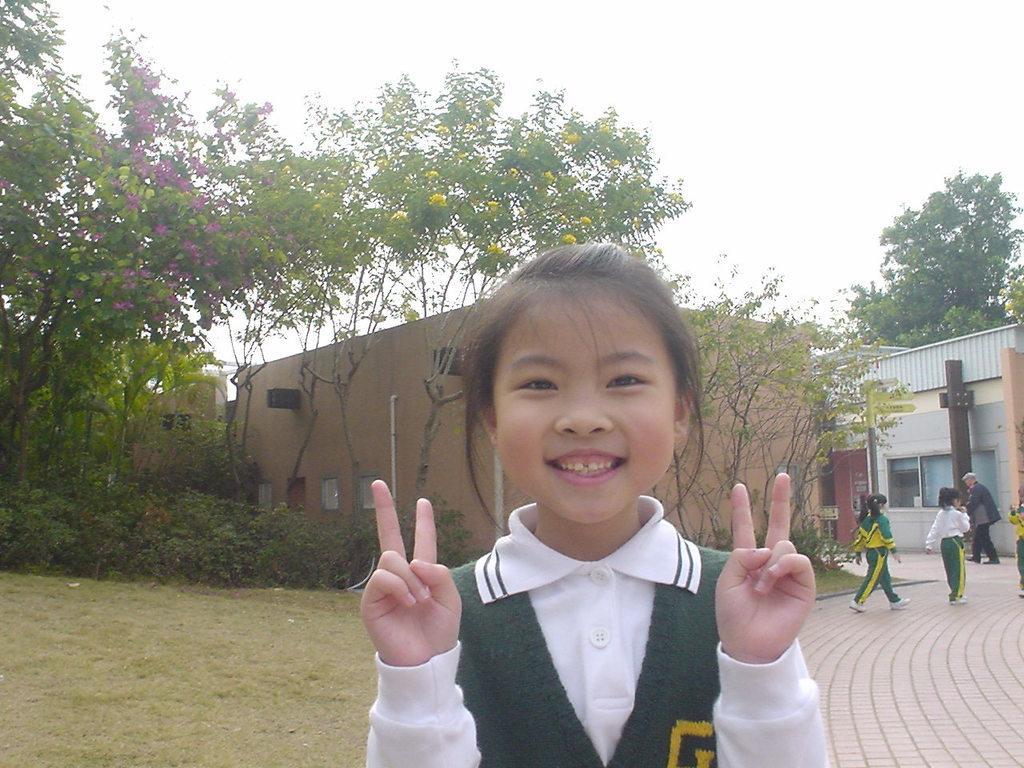In one or two sentences, can you explain what this image depicts? In this image we can see a few people and some grass, plants, trees, flowers, there are few houses and pipelines. 